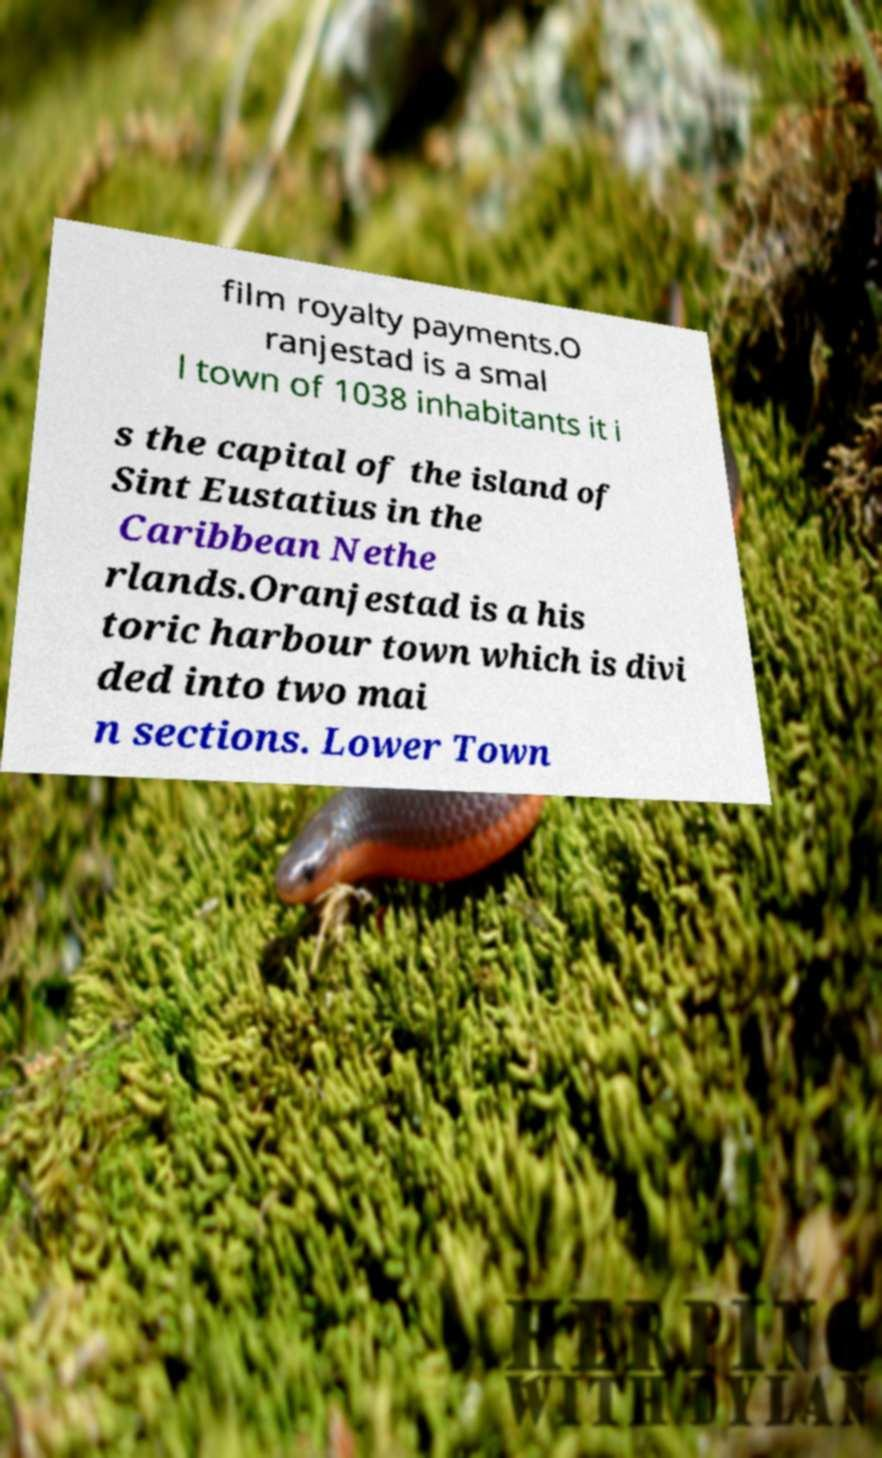Could you extract and type out the text from this image? film royalty payments.O ranjestad is a smal l town of 1038 inhabitants it i s the capital of the island of Sint Eustatius in the Caribbean Nethe rlands.Oranjestad is a his toric harbour town which is divi ded into two mai n sections. Lower Town 